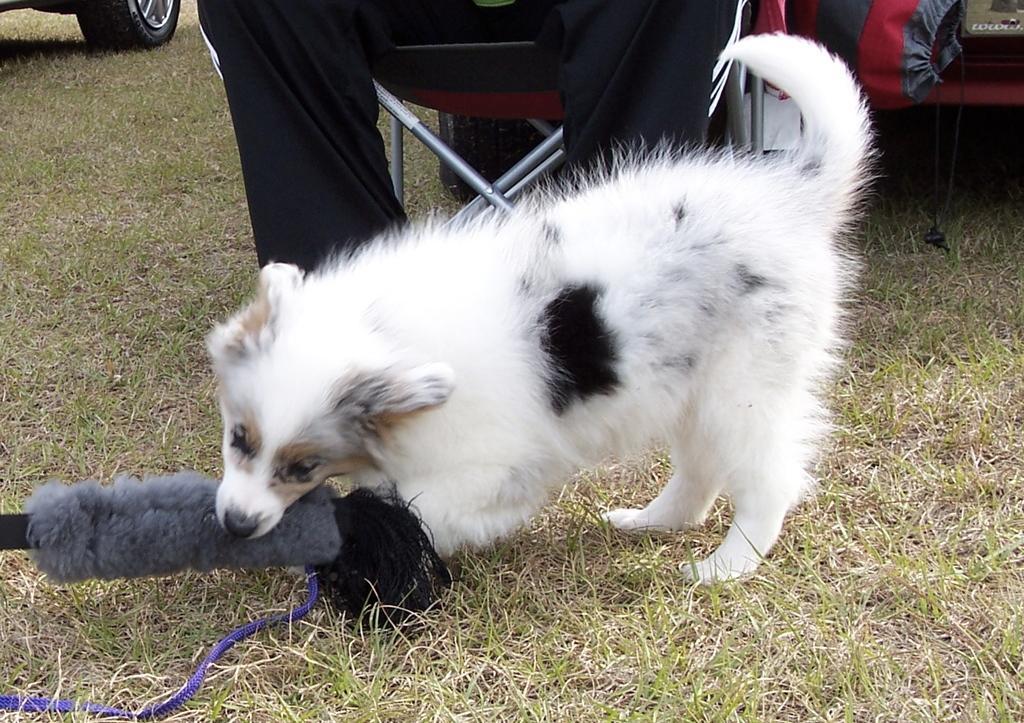How would you summarize this image in a sentence or two? In this picture we can see white dog on the grass ground. Behind there is a man wearing a black track and sitting on the chair. 